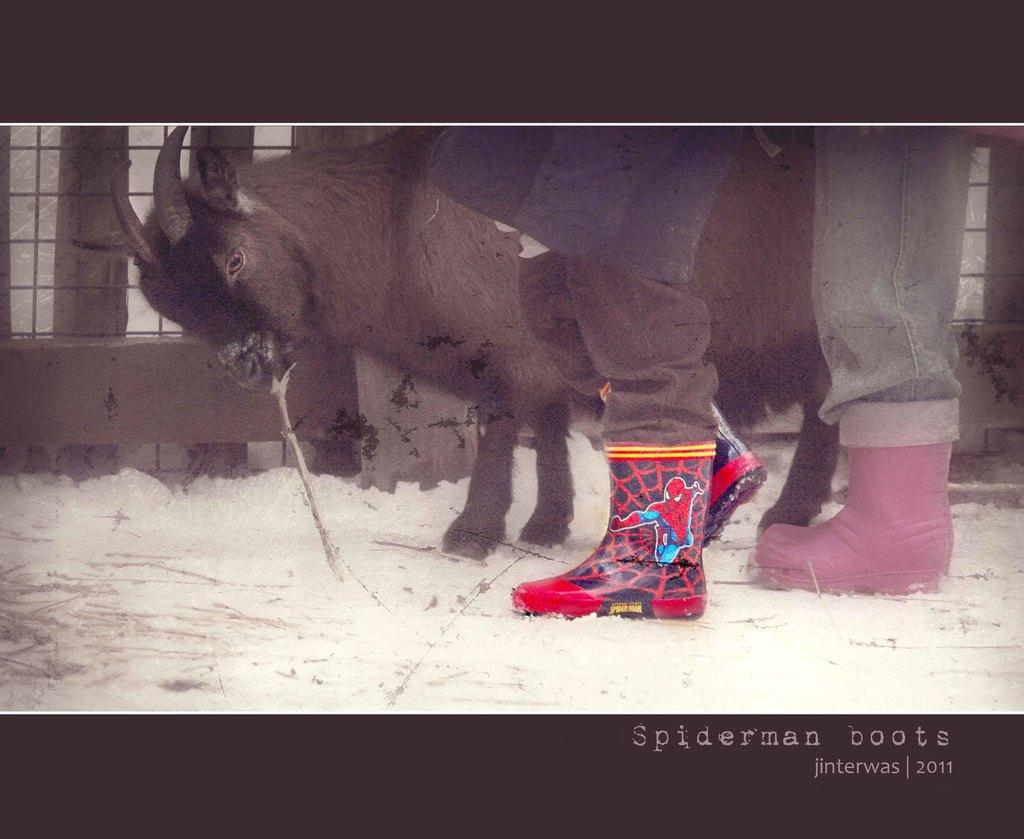What animal is present in the image? There is a buffalo in the image. Can you see any human presence in the image? Yes, the legs of a person are visible in the image. What type of structure can be seen in the background of the image? There is a building in the background of the image. What is the condition of the surface in the background of the image? There is snow on the surface in the background of the image. What type of caption is written on the buffalo in the image? There is no caption written on the buffalo in the image. Can you describe the coastline visible in the image? There is no coastline visible in the image; it features a buffalo, a person's legs, a building, and snowy terrain. 